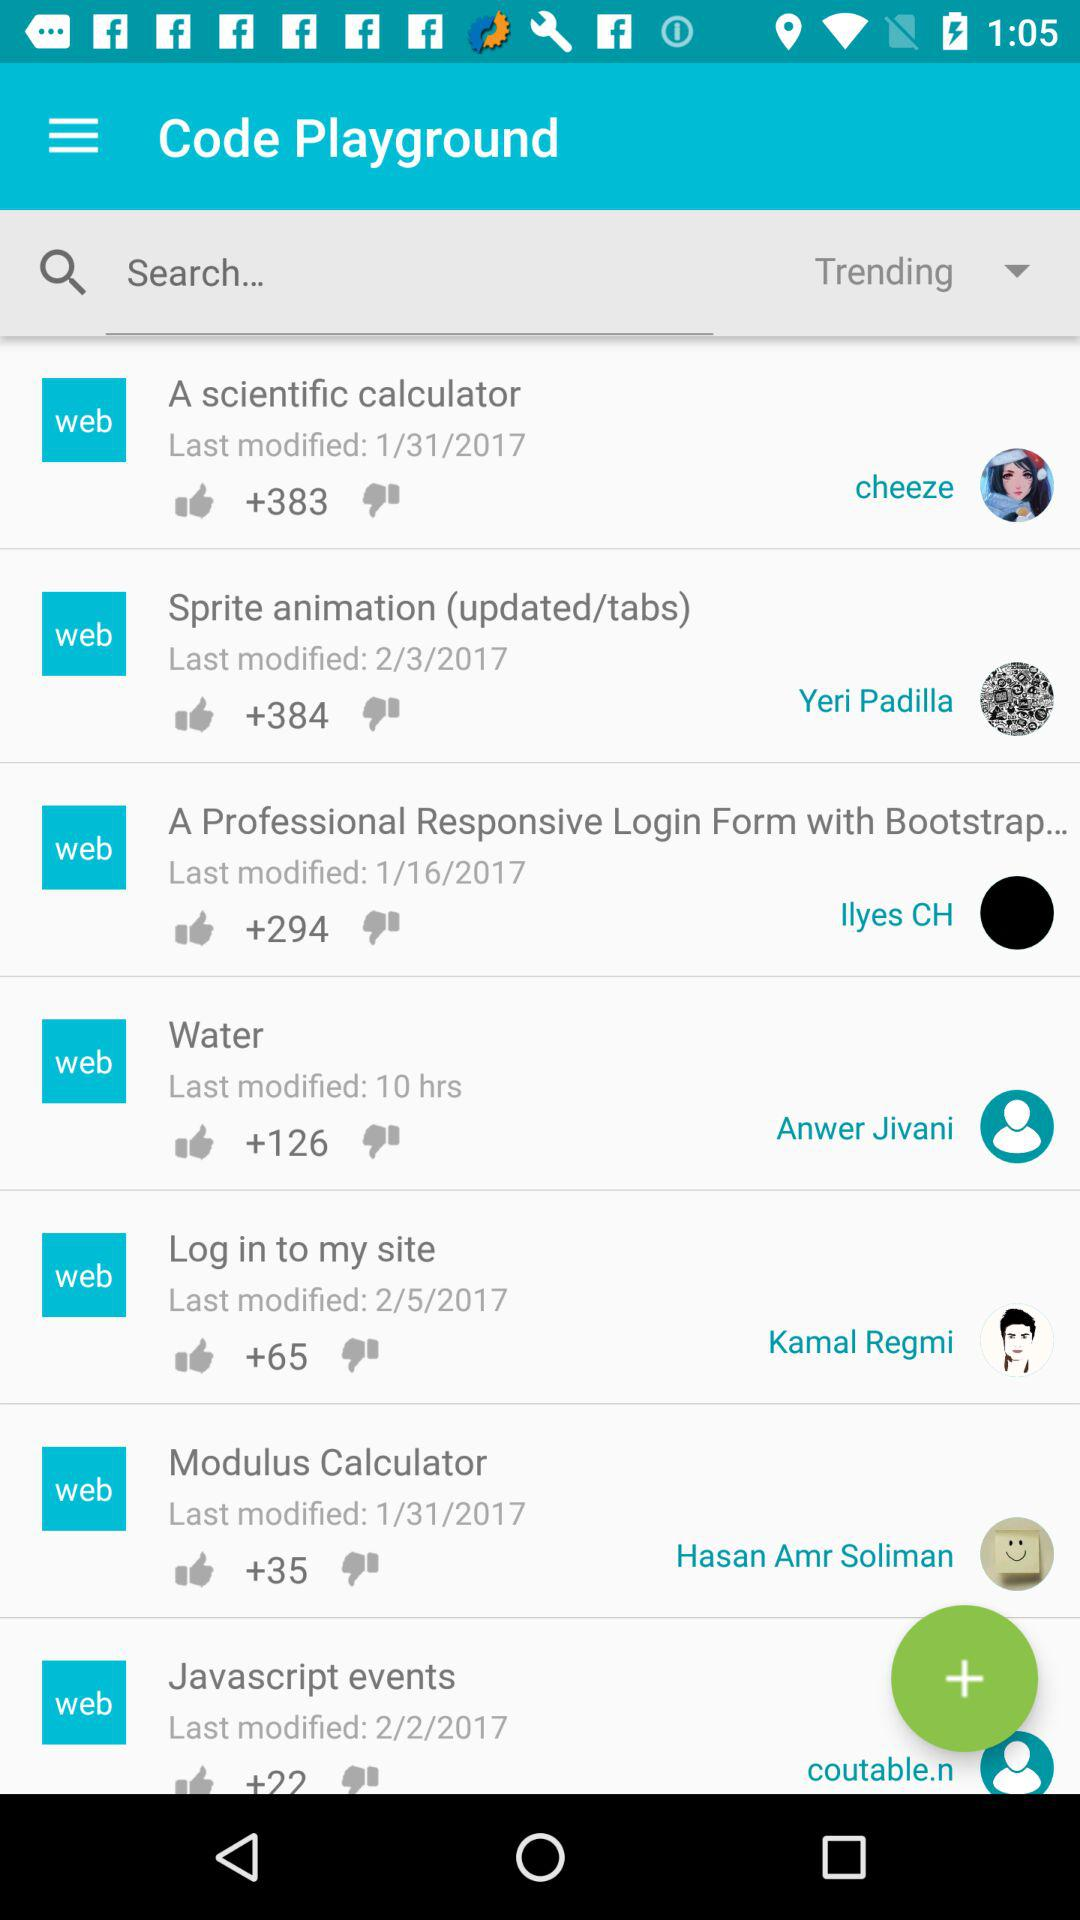What is the last modified date of the modulus calculator? The last modified date is January 31, 2017. 